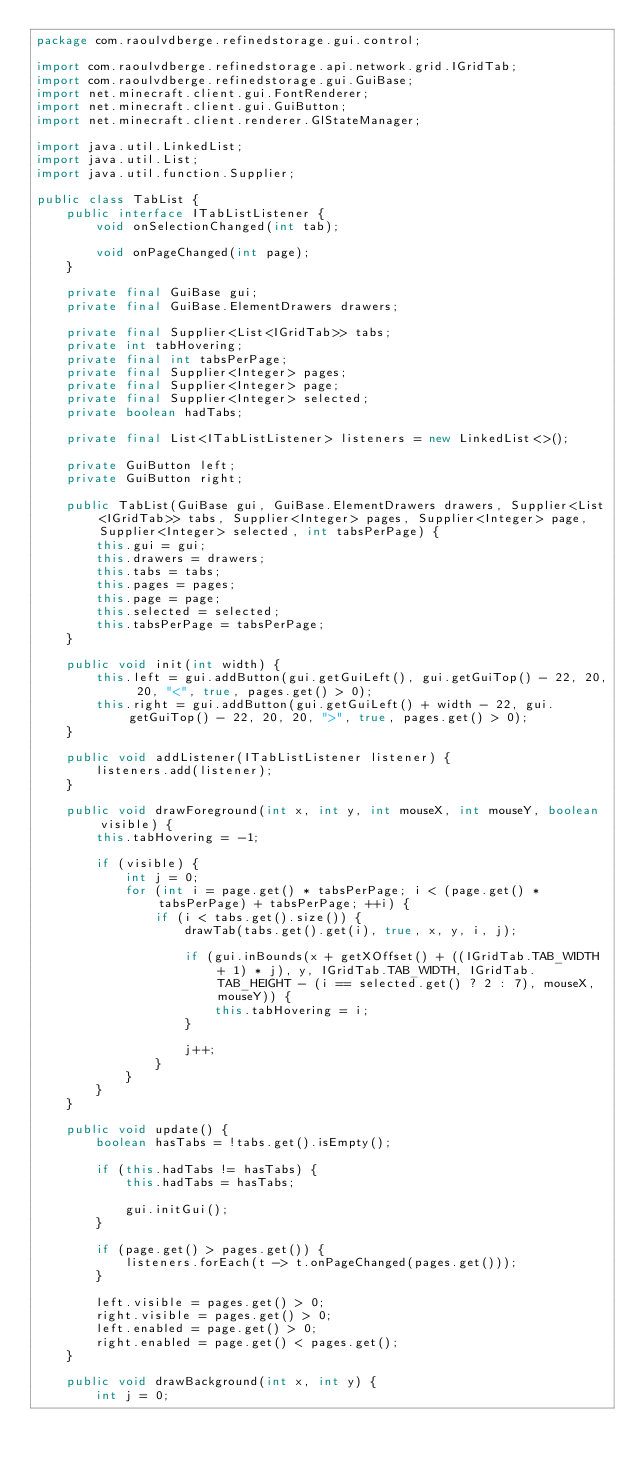Convert code to text. <code><loc_0><loc_0><loc_500><loc_500><_Java_>package com.raoulvdberge.refinedstorage.gui.control;

import com.raoulvdberge.refinedstorage.api.network.grid.IGridTab;
import com.raoulvdberge.refinedstorage.gui.GuiBase;
import net.minecraft.client.gui.FontRenderer;
import net.minecraft.client.gui.GuiButton;
import net.minecraft.client.renderer.GlStateManager;

import java.util.LinkedList;
import java.util.List;
import java.util.function.Supplier;

public class TabList {
    public interface ITabListListener {
        void onSelectionChanged(int tab);

        void onPageChanged(int page);
    }

    private final GuiBase gui;
    private final GuiBase.ElementDrawers drawers;

    private final Supplier<List<IGridTab>> tabs;
    private int tabHovering;
    private final int tabsPerPage;
    private final Supplier<Integer> pages;
    private final Supplier<Integer> page;
    private final Supplier<Integer> selected;
    private boolean hadTabs;

    private final List<ITabListListener> listeners = new LinkedList<>();

    private GuiButton left;
    private GuiButton right;

    public TabList(GuiBase gui, GuiBase.ElementDrawers drawers, Supplier<List<IGridTab>> tabs, Supplier<Integer> pages, Supplier<Integer> page, Supplier<Integer> selected, int tabsPerPage) {
        this.gui = gui;
        this.drawers = drawers;
        this.tabs = tabs;
        this.pages = pages;
        this.page = page;
        this.selected = selected;
        this.tabsPerPage = tabsPerPage;
    }

    public void init(int width) {
        this.left = gui.addButton(gui.getGuiLeft(), gui.getGuiTop() - 22, 20, 20, "<", true, pages.get() > 0);
        this.right = gui.addButton(gui.getGuiLeft() + width - 22, gui.getGuiTop() - 22, 20, 20, ">", true, pages.get() > 0);
    }

    public void addListener(ITabListListener listener) {
        listeners.add(listener);
    }

    public void drawForeground(int x, int y, int mouseX, int mouseY, boolean visible) {
        this.tabHovering = -1;

        if (visible) {
            int j = 0;
            for (int i = page.get() * tabsPerPage; i < (page.get() * tabsPerPage) + tabsPerPage; ++i) {
                if (i < tabs.get().size()) {
                    drawTab(tabs.get().get(i), true, x, y, i, j);

                    if (gui.inBounds(x + getXOffset() + ((IGridTab.TAB_WIDTH + 1) * j), y, IGridTab.TAB_WIDTH, IGridTab.TAB_HEIGHT - (i == selected.get() ? 2 : 7), mouseX, mouseY)) {
                        this.tabHovering = i;
                    }

                    j++;
                }
            }
        }
    }

    public void update() {
        boolean hasTabs = !tabs.get().isEmpty();

        if (this.hadTabs != hasTabs) {
            this.hadTabs = hasTabs;

            gui.initGui();
        }

        if (page.get() > pages.get()) {
            listeners.forEach(t -> t.onPageChanged(pages.get()));
        }

        left.visible = pages.get() > 0;
        right.visible = pages.get() > 0;
        left.enabled = page.get() > 0;
        right.enabled = page.get() < pages.get();
    }

    public void drawBackground(int x, int y) {
        int j = 0;</code> 